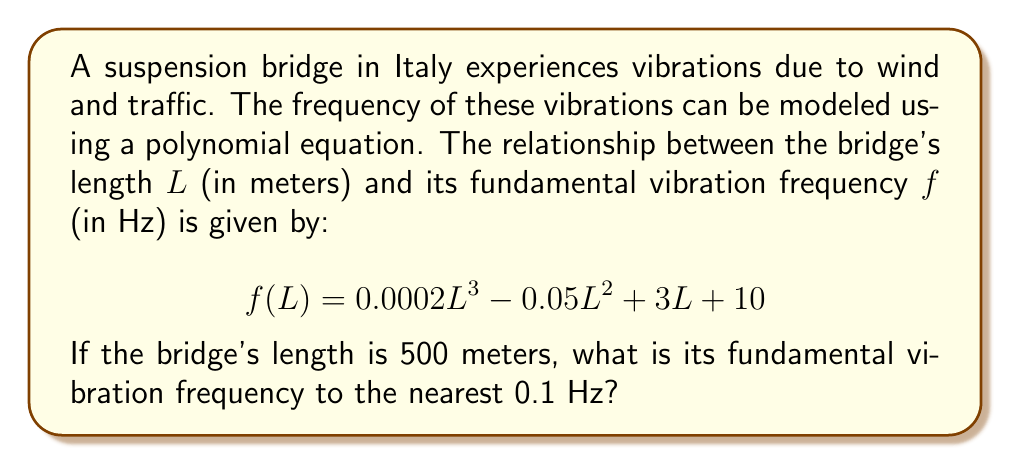Can you solve this math problem? To solve this problem, we need to follow these steps:

1) We have the polynomial equation:
   $$ f(L) = 0.0002L^3 - 0.05L^2 + 3L + 10 $$

2) We know the bridge length $L = 500$ meters. Let's substitute this into our equation:
   $$ f(500) = 0.0002(500)^3 - 0.05(500)^2 + 3(500) + 10 $$

3) Let's calculate each term:
   - $0.0002(500)^3 = 0.0002 \times 125,000,000 = 25,000$
   - $-0.05(500)^2 = -0.05 \times 250,000 = -12,500$
   - $3(500) = 1,500$
   - The constant term is 10

4) Now, let's sum these terms:
   $$ f(500) = 25,000 - 12,500 + 1,500 + 10 = 14,010 $$

5) The question asks for the answer to the nearest 0.1 Hz, so we need to round 14,010 to one decimal place.
Answer: 14,010.0 Hz 